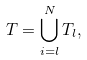Convert formula to latex. <formula><loc_0><loc_0><loc_500><loc_500>T = \bigcup _ { i = l } ^ { N } T _ { l } ,</formula> 